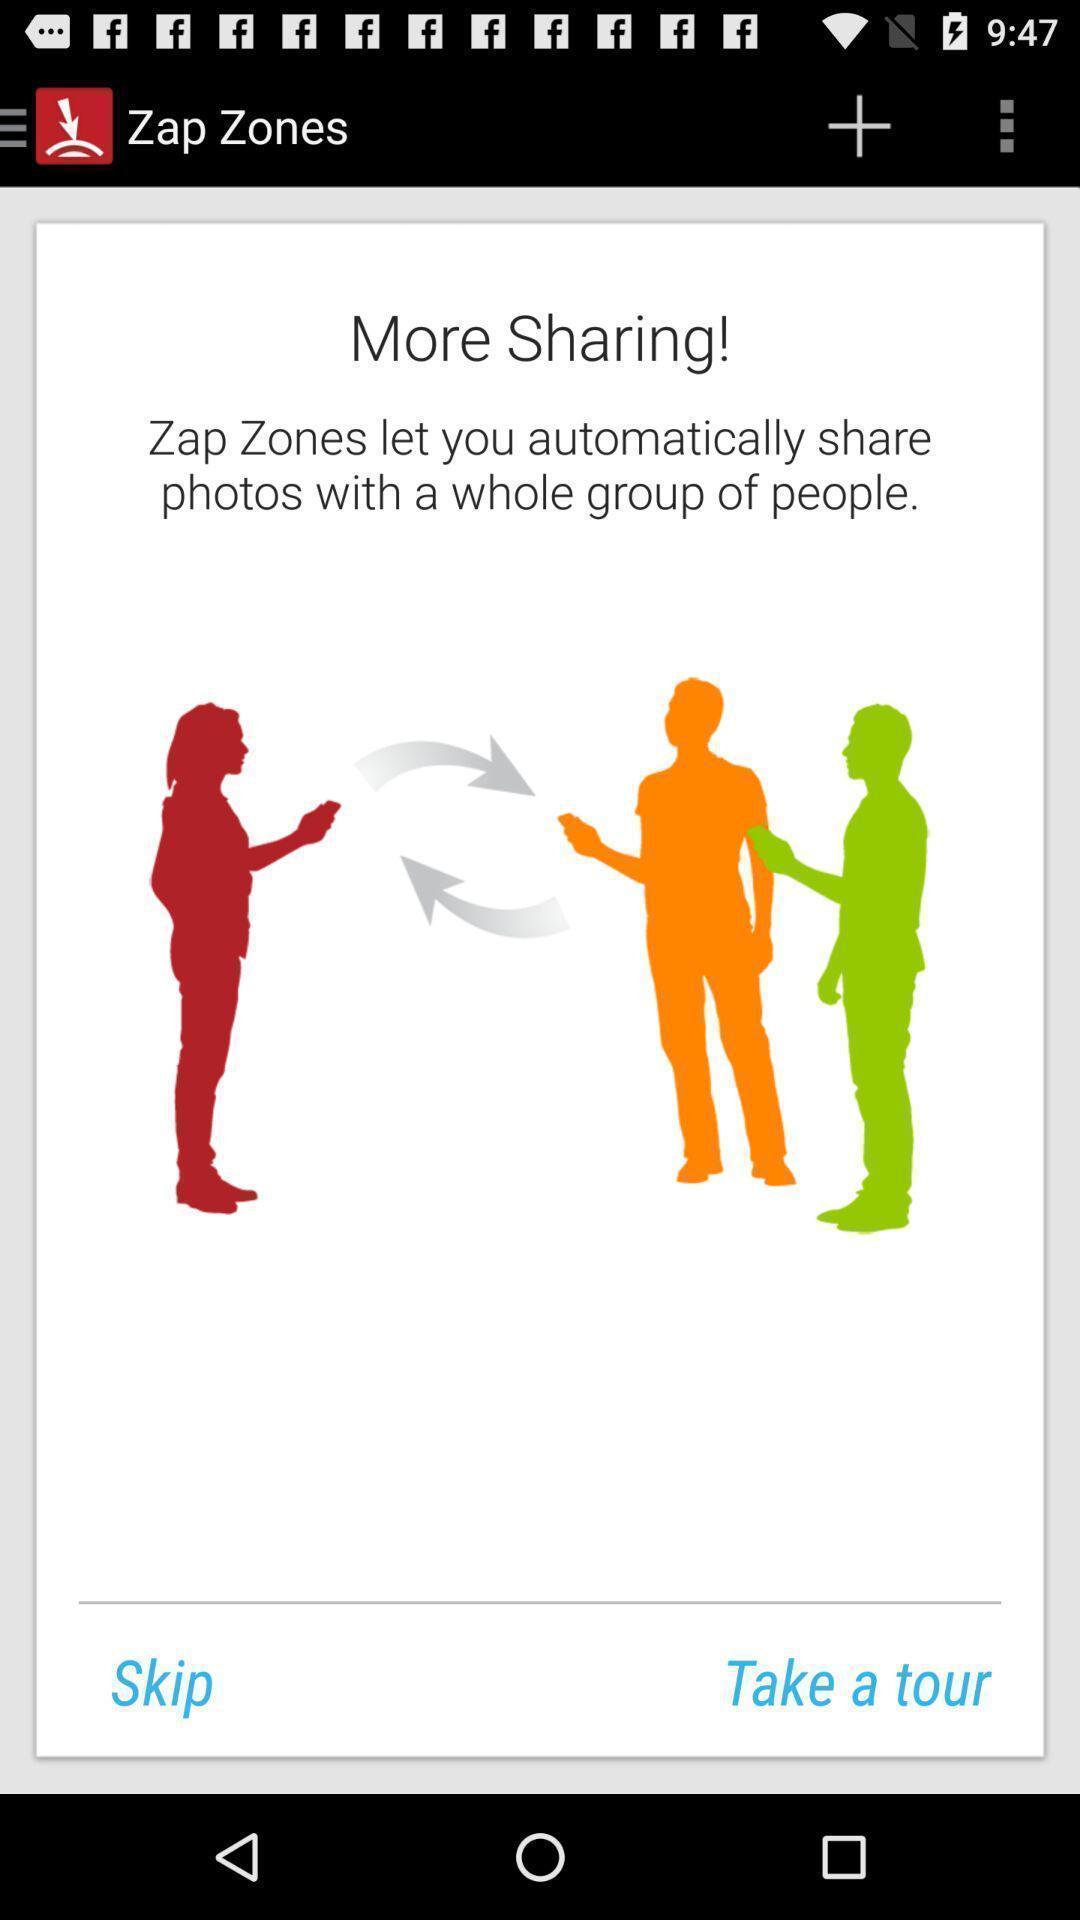Provide a description of this screenshot. Welcome page for a file sharing app. 